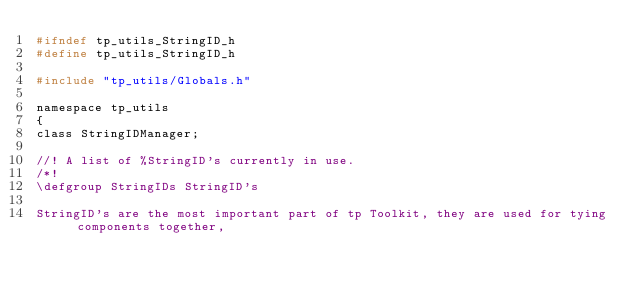Convert code to text. <code><loc_0><loc_0><loc_500><loc_500><_C_>#ifndef tp_utils_StringID_h
#define tp_utils_StringID_h

#include "tp_utils/Globals.h"

namespace tp_utils
{
class StringIDManager;

//! A list of %StringID's currently in use.
/*!
\defgroup StringIDs StringID's

StringID's are the most important part of tp Toolkit, they are used for tying components together,</code> 